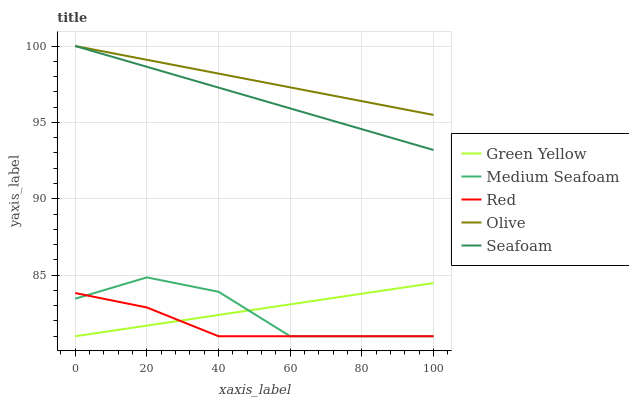Does Red have the minimum area under the curve?
Answer yes or no. Yes. Does Olive have the maximum area under the curve?
Answer yes or no. Yes. Does Green Yellow have the minimum area under the curve?
Answer yes or no. No. Does Green Yellow have the maximum area under the curve?
Answer yes or no. No. Is Olive the smoothest?
Answer yes or no. Yes. Is Medium Seafoam the roughest?
Answer yes or no. Yes. Is Green Yellow the smoothest?
Answer yes or no. No. Is Green Yellow the roughest?
Answer yes or no. No. Does Green Yellow have the lowest value?
Answer yes or no. Yes. Does Seafoam have the lowest value?
Answer yes or no. No. Does Seafoam have the highest value?
Answer yes or no. Yes. Does Green Yellow have the highest value?
Answer yes or no. No. Is Medium Seafoam less than Seafoam?
Answer yes or no. Yes. Is Seafoam greater than Medium Seafoam?
Answer yes or no. Yes. Does Red intersect Medium Seafoam?
Answer yes or no. Yes. Is Red less than Medium Seafoam?
Answer yes or no. No. Is Red greater than Medium Seafoam?
Answer yes or no. No. Does Medium Seafoam intersect Seafoam?
Answer yes or no. No. 